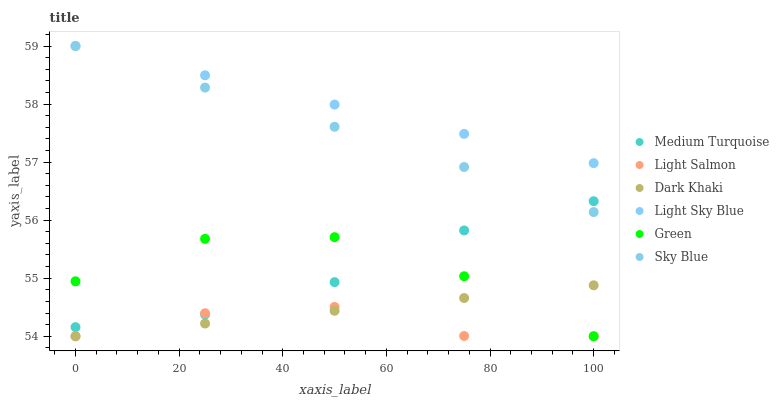Does Light Salmon have the minimum area under the curve?
Answer yes or no. Yes. Does Light Sky Blue have the maximum area under the curve?
Answer yes or no. Yes. Does Dark Khaki have the minimum area under the curve?
Answer yes or no. No. Does Dark Khaki have the maximum area under the curve?
Answer yes or no. No. Is Light Sky Blue the smoothest?
Answer yes or no. Yes. Is Green the roughest?
Answer yes or no. Yes. Is Dark Khaki the smoothest?
Answer yes or no. No. Is Dark Khaki the roughest?
Answer yes or no. No. Does Light Salmon have the lowest value?
Answer yes or no. Yes. Does Light Sky Blue have the lowest value?
Answer yes or no. No. Does Sky Blue have the highest value?
Answer yes or no. Yes. Does Dark Khaki have the highest value?
Answer yes or no. No. Is Light Salmon less than Sky Blue?
Answer yes or no. Yes. Is Light Sky Blue greater than Dark Khaki?
Answer yes or no. Yes. Does Light Salmon intersect Green?
Answer yes or no. Yes. Is Light Salmon less than Green?
Answer yes or no. No. Is Light Salmon greater than Green?
Answer yes or no. No. Does Light Salmon intersect Sky Blue?
Answer yes or no. No. 